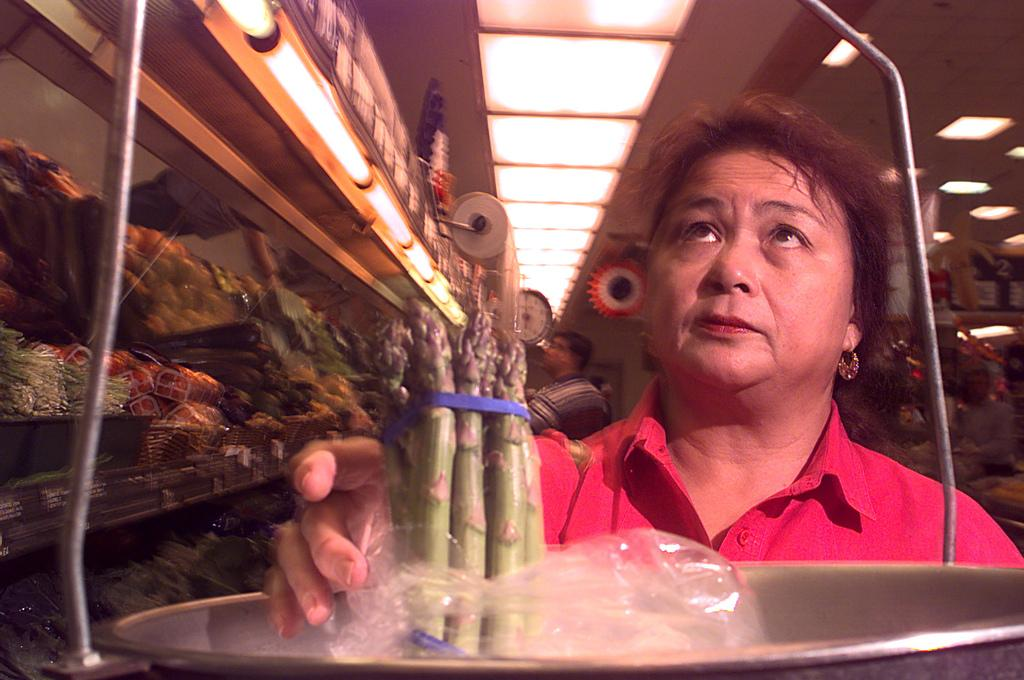What is happening in the image? There are people in the shop. What can be seen on the weighing machine? There is an item in the weighing machine. What is available for purchase in the shop? There are items on the shelves. How is the shop illuminated? There are lights attached to the roof. Are there any tents or farmers visible in the image? No, there are no tents or farmers present in the image. How many horses can be seen in the shop? There are no horses visible in the image. 